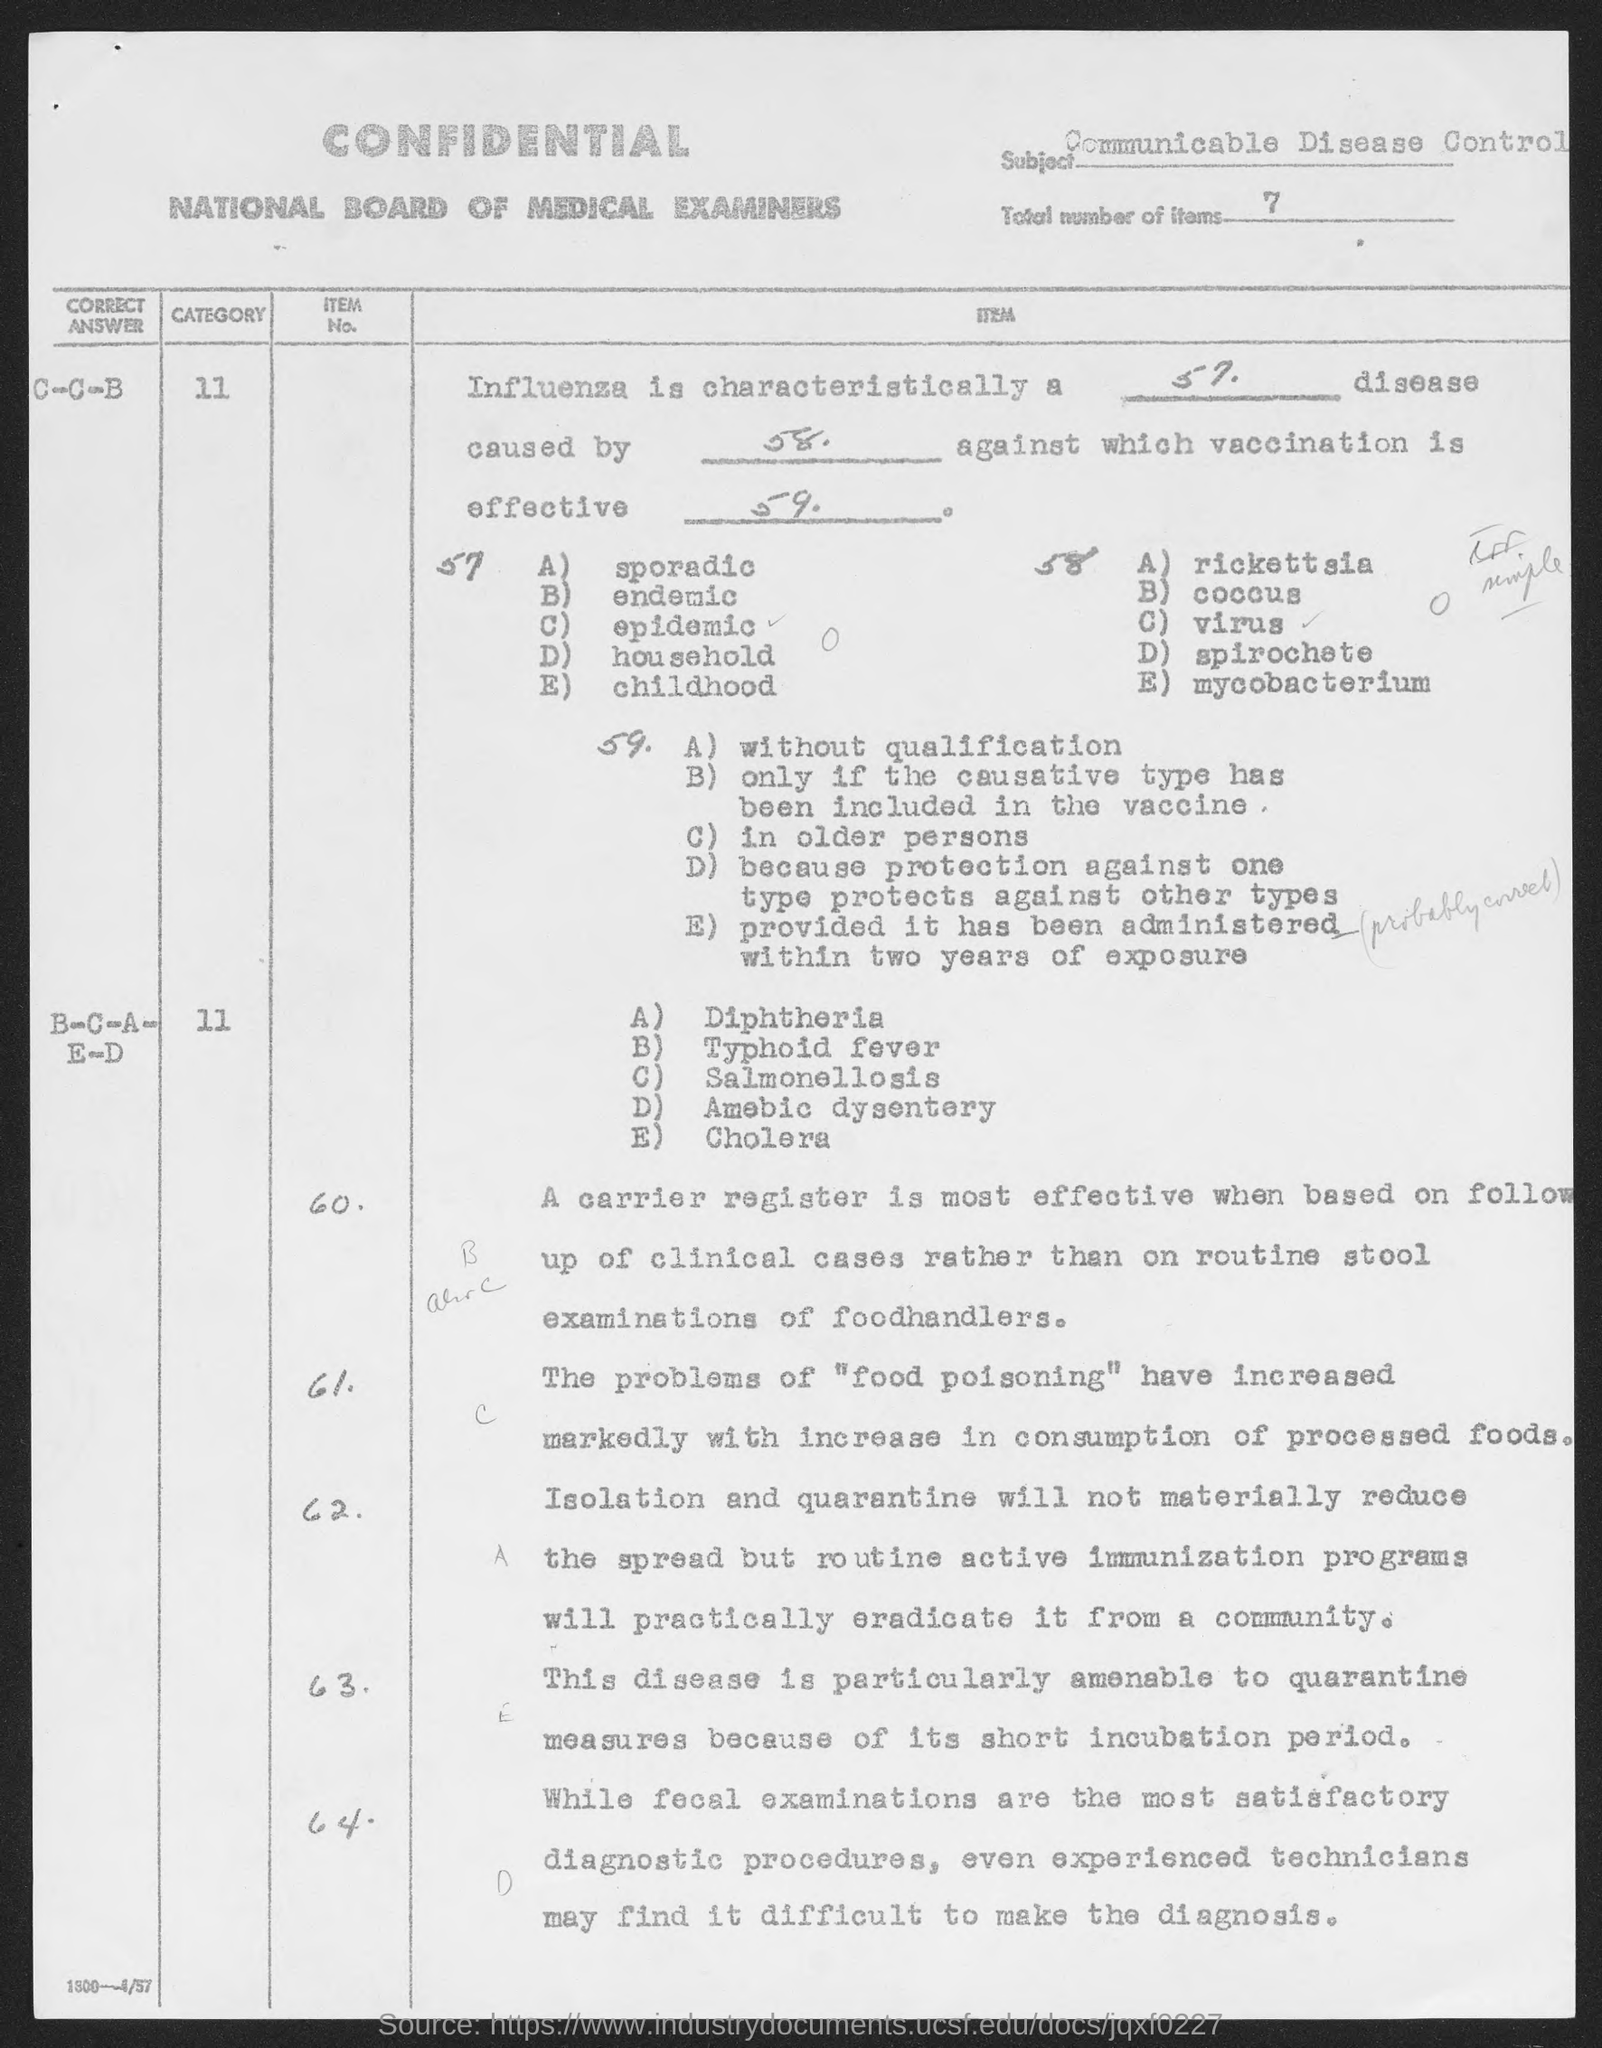What is the subject name ?
Offer a terse response. Communicable Disease control. What is the total number of items?
Offer a terse response. 7. 